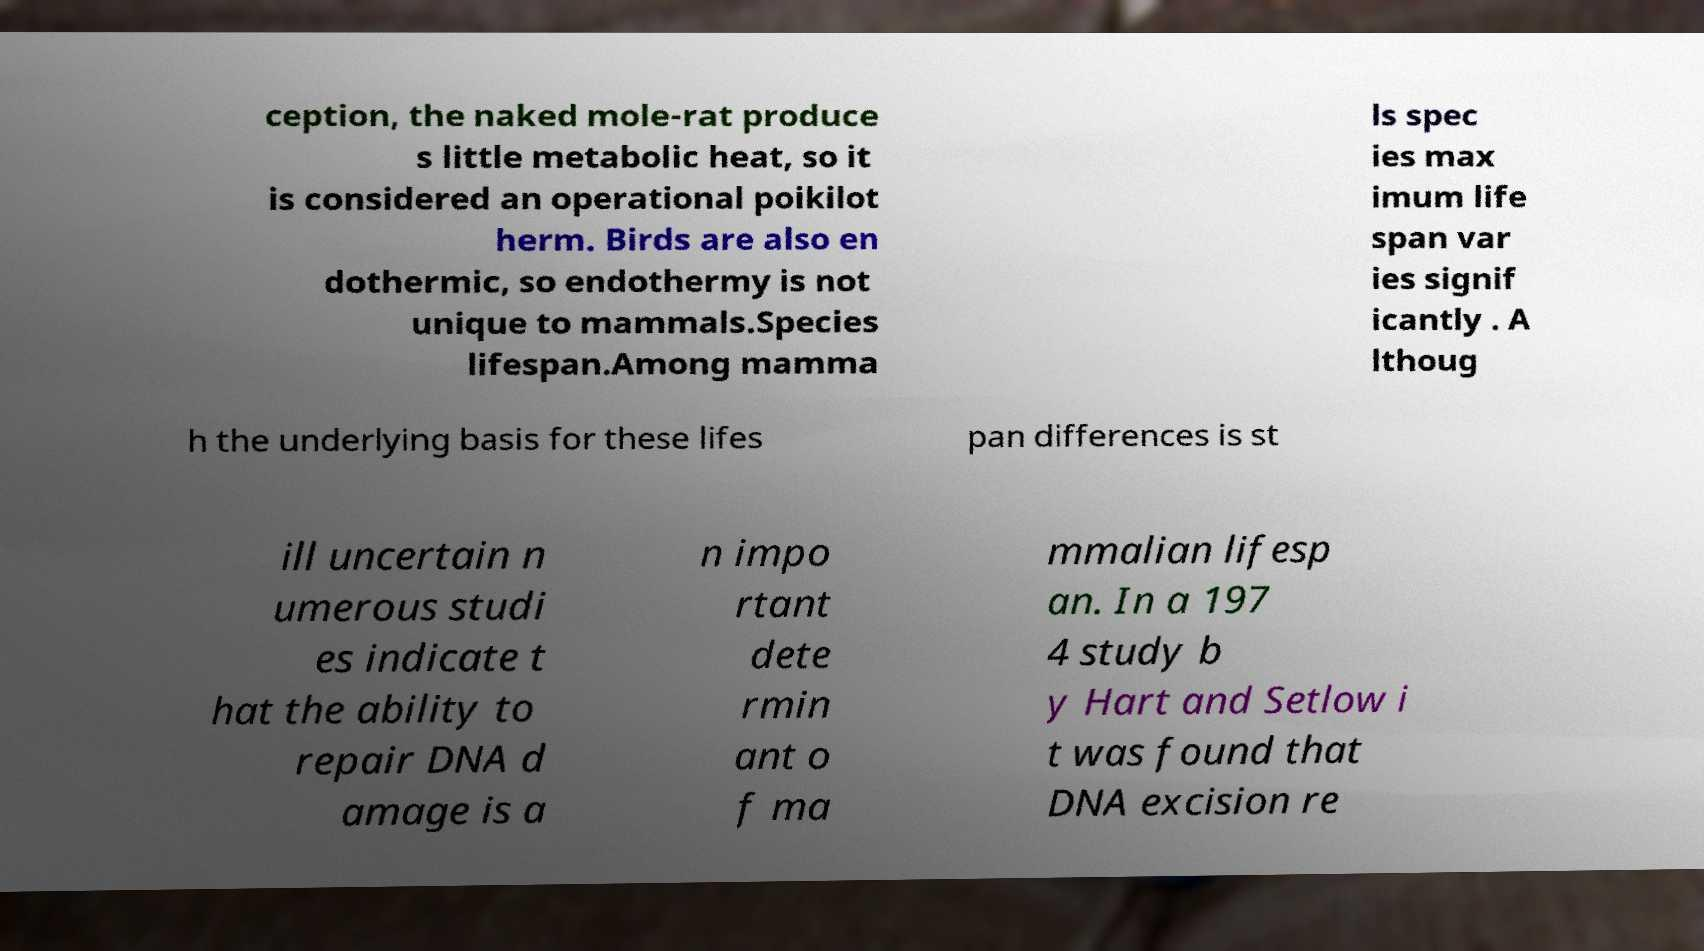For documentation purposes, I need the text within this image transcribed. Could you provide that? ception, the naked mole-rat produce s little metabolic heat, so it is considered an operational poikilot herm. Birds are also en dothermic, so endothermy is not unique to mammals.Species lifespan.Among mamma ls spec ies max imum life span var ies signif icantly . A lthoug h the underlying basis for these lifes pan differences is st ill uncertain n umerous studi es indicate t hat the ability to repair DNA d amage is a n impo rtant dete rmin ant o f ma mmalian lifesp an. In a 197 4 study b y Hart and Setlow i t was found that DNA excision re 